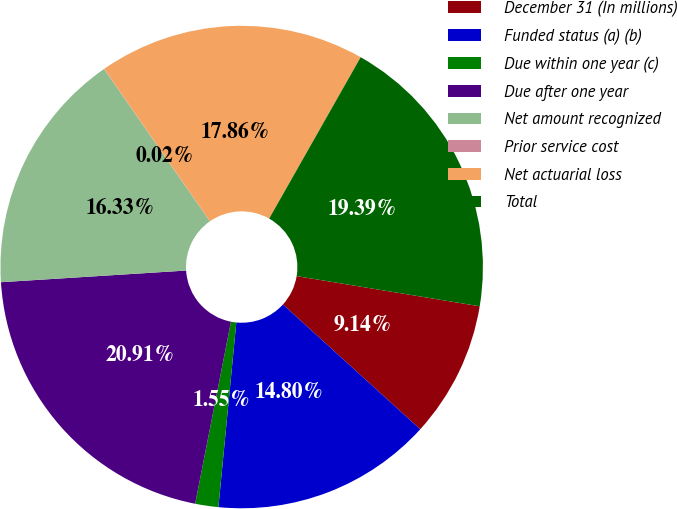<chart> <loc_0><loc_0><loc_500><loc_500><pie_chart><fcel>December 31 (In millions)<fcel>Funded status (a) (b)<fcel>Due within one year (c)<fcel>Due after one year<fcel>Net amount recognized<fcel>Prior service cost<fcel>Net actuarial loss<fcel>Total<nl><fcel>9.14%<fcel>14.8%<fcel>1.55%<fcel>20.91%<fcel>16.33%<fcel>0.02%<fcel>17.86%<fcel>19.39%<nl></chart> 